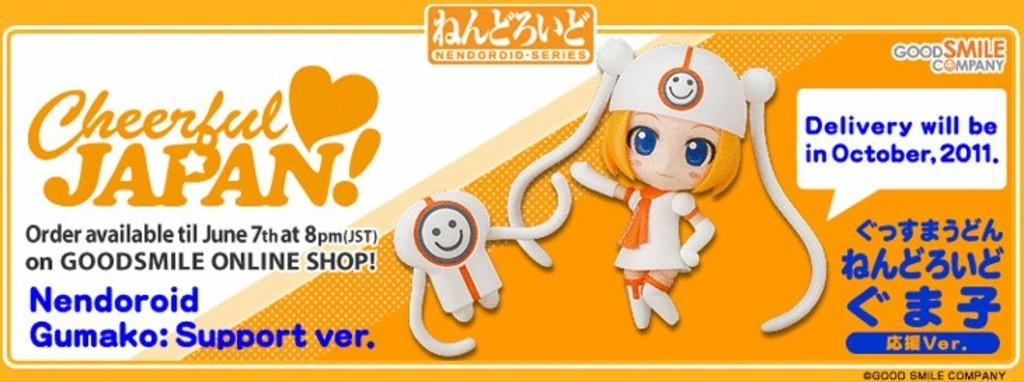What can be found in the foreground of the poster? In the foreground of the poster, there is text, an image of a girl, and an image of a toy. Can you describe the image of the girl? The image of the girl is in the foreground of the poster. What else is depicted in the foreground of the poster besides the girl? There is also an image of a toy in the foreground of the poster. What type of disease is the girl suffering from in the image? There is no indication of any disease in the image; it only features an image of a girl and a toy. How does the drum contribute to the poster's message? There is no drum present in the image, so it cannot contribute to the poster's message. 